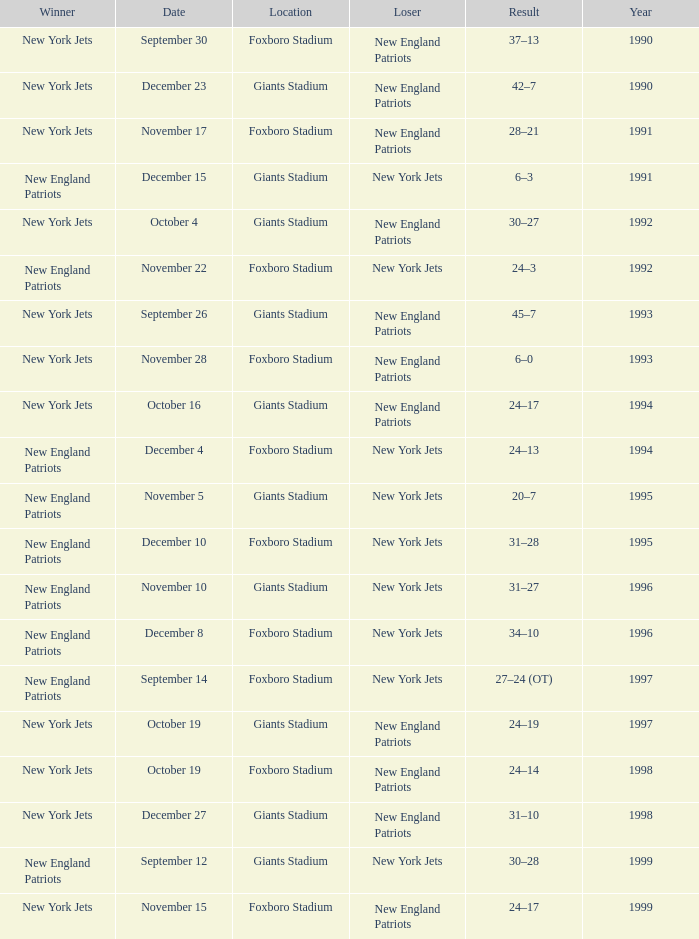Write the full table. {'header': ['Winner', 'Date', 'Location', 'Loser', 'Result', 'Year'], 'rows': [['New York Jets', 'September 30', 'Foxboro Stadium', 'New England Patriots', '37–13', '1990'], ['New York Jets', 'December 23', 'Giants Stadium', 'New England Patriots', '42–7', '1990'], ['New York Jets', 'November 17', 'Foxboro Stadium', 'New England Patriots', '28–21', '1991'], ['New England Patriots', 'December 15', 'Giants Stadium', 'New York Jets', '6–3', '1991'], ['New York Jets', 'October 4', 'Giants Stadium', 'New England Patriots', '30–27', '1992'], ['New England Patriots', 'November 22', 'Foxboro Stadium', 'New York Jets', '24–3', '1992'], ['New York Jets', 'September 26', 'Giants Stadium', 'New England Patriots', '45–7', '1993'], ['New York Jets', 'November 28', 'Foxboro Stadium', 'New England Patriots', '6–0', '1993'], ['New York Jets', 'October 16', 'Giants Stadium', 'New England Patriots', '24–17', '1994'], ['New England Patriots', 'December 4', 'Foxboro Stadium', 'New York Jets', '24–13', '1994'], ['New England Patriots', 'November 5', 'Giants Stadium', 'New York Jets', '20–7', '1995'], ['New England Patriots', 'December 10', 'Foxboro Stadium', 'New York Jets', '31–28', '1995'], ['New England Patriots', 'November 10', 'Giants Stadium', 'New York Jets', '31–27', '1996'], ['New England Patriots', 'December 8', 'Foxboro Stadium', 'New York Jets', '34–10', '1996'], ['New England Patriots', 'September 14', 'Foxboro Stadium', 'New York Jets', '27–24 (OT)', '1997'], ['New York Jets', 'October 19', 'Giants Stadium', 'New England Patriots', '24–19', '1997'], ['New York Jets', 'October 19', 'Foxboro Stadium', 'New England Patriots', '24–14', '1998'], ['New York Jets', 'December 27', 'Giants Stadium', 'New England Patriots', '31–10', '1998'], ['New England Patriots', 'September 12', 'Giants Stadium', 'New York Jets', '30–28', '1999'], ['New York Jets', 'November 15', 'Foxboro Stadium', 'New England Patriots', '24–17', '1999']]} What team was the lower when the winner was the new york jets, and a Year earlier than 1994, and a Result of 37–13? New England Patriots. 